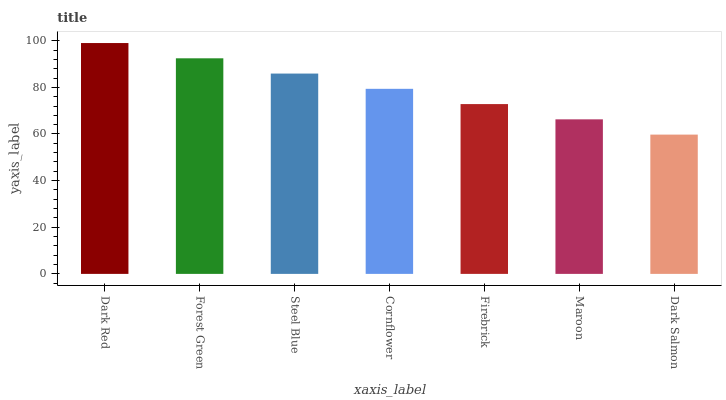Is Dark Salmon the minimum?
Answer yes or no. Yes. Is Dark Red the maximum?
Answer yes or no. Yes. Is Forest Green the minimum?
Answer yes or no. No. Is Forest Green the maximum?
Answer yes or no. No. Is Dark Red greater than Forest Green?
Answer yes or no. Yes. Is Forest Green less than Dark Red?
Answer yes or no. Yes. Is Forest Green greater than Dark Red?
Answer yes or no. No. Is Dark Red less than Forest Green?
Answer yes or no. No. Is Cornflower the high median?
Answer yes or no. Yes. Is Cornflower the low median?
Answer yes or no. Yes. Is Maroon the high median?
Answer yes or no. No. Is Dark Salmon the low median?
Answer yes or no. No. 